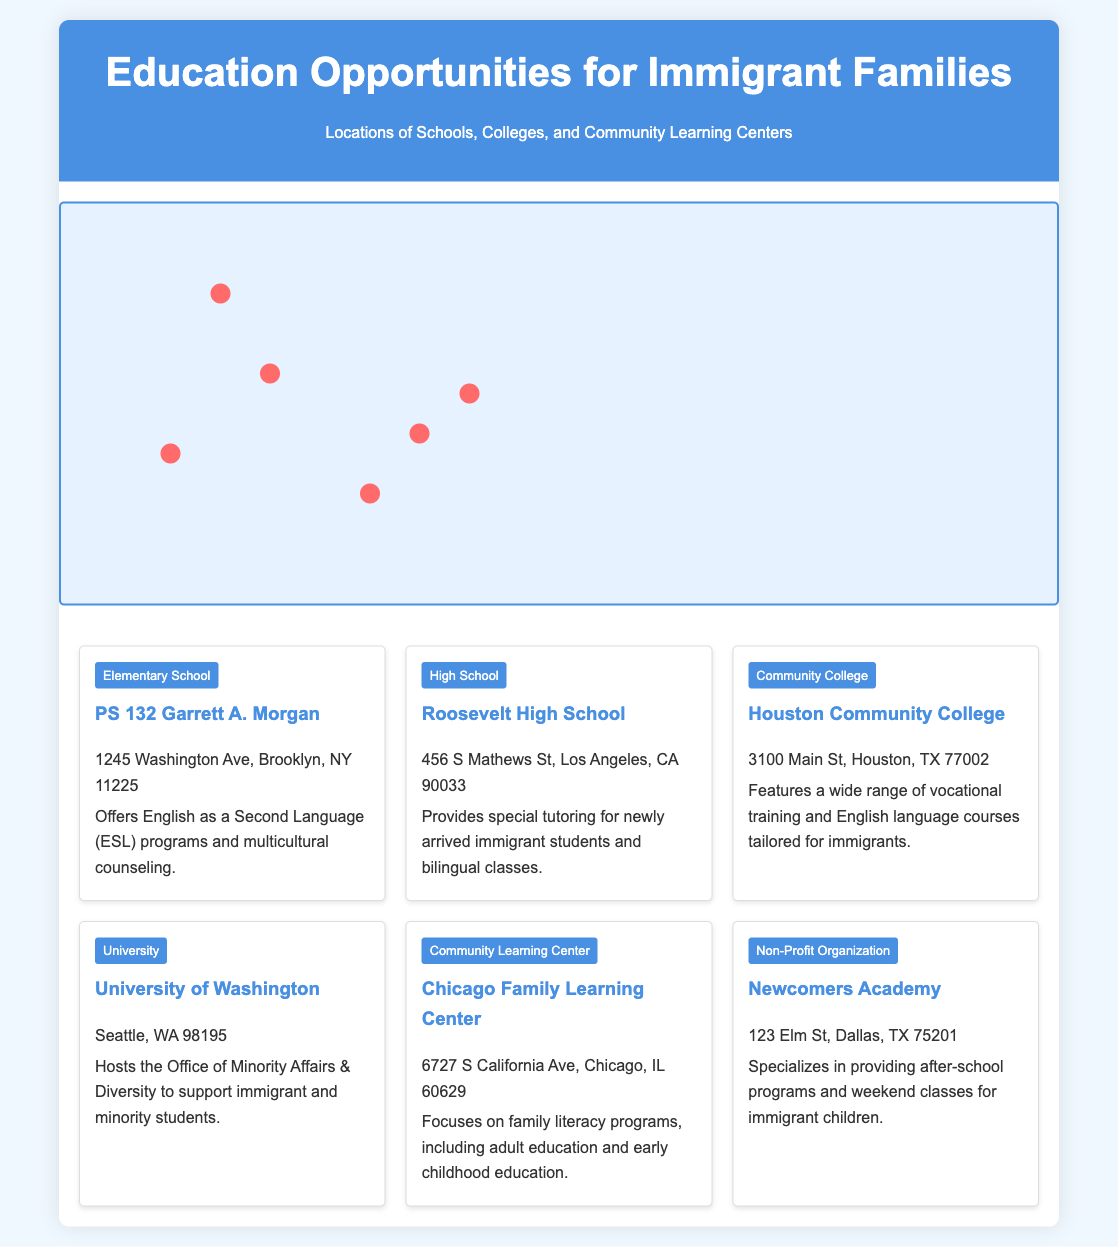What school offers ESL programs? The document indicates that PS 132 Garrett A. Morgan offers English as a Second Language (ESL) programs.
Answer: PS 132 Garrett A. Morgan Where is Roosevelt High School located? The location of Roosevelt High School is provided in the document as 456 S Mathews St, Los Angeles, CA 90033.
Answer: 456 S Mathews St, Los Angeles, CA 90033 What type of institution is Houston Community College? The document categorizes Houston Community College as a community college, highlighting its vocational training offerings.
Answer: Community College Which center focuses on family literacy programs? The Chicago Family Learning Center is specifically mentioned as focusing on family literacy programs.
Answer: Chicago Family Learning Center How many educational locations are listed in the document? By counting the locations, the document lists a total of six educational opportunities for immigrant families.
Answer: 6 What support does the University of Washington offer? The document states that the University of Washington hosts the Office of Minority Affairs & Diversity to support certain student demographics.
Answer: Office of Minority Affairs & Diversity What type of classes does Newcomers Academy provide? The document notes that Newcomers Academy specializes in after-school programs and weekend classes specifically for immigrant children.
Answer: After-school programs What city is the Chicago Family Learning Center located in? The document specifies that the Chicago Family Learning Center is located in Chicago, IL.
Answer: Chicago Which school provides bilingual classes? The document indicates that Roosevelt High School provides bilingual classes for newly arrived immigrant students.
Answer: Roosevelt High School 